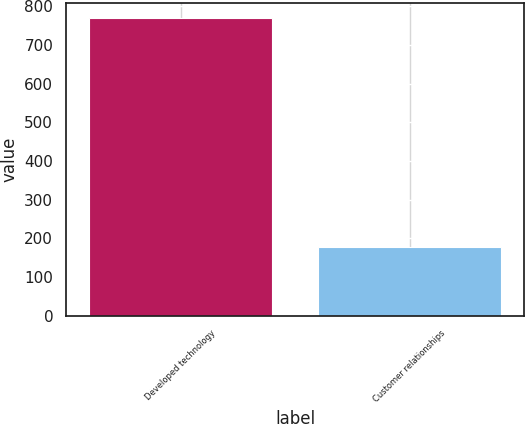Convert chart. <chart><loc_0><loc_0><loc_500><loc_500><bar_chart><fcel>Developed technology<fcel>Customer relationships<nl><fcel>769<fcel>177<nl></chart> 